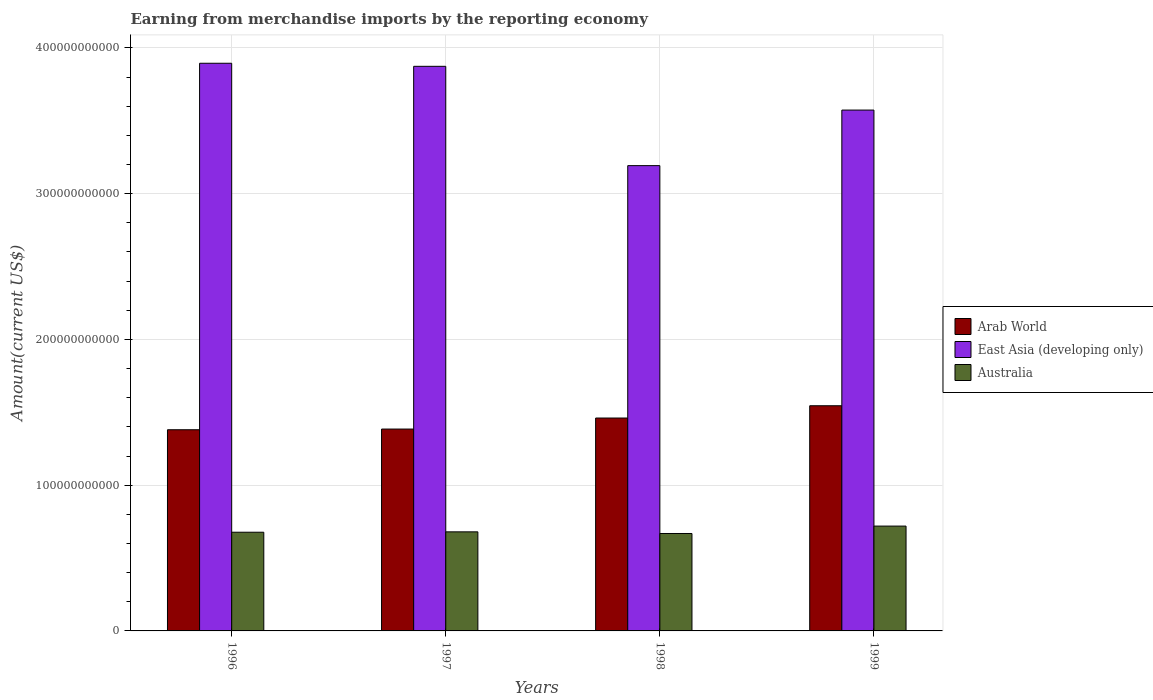How many groups of bars are there?
Offer a very short reply. 4. Are the number of bars per tick equal to the number of legend labels?
Offer a very short reply. Yes. Are the number of bars on each tick of the X-axis equal?
Your answer should be compact. Yes. How many bars are there on the 2nd tick from the left?
Offer a terse response. 3. How many bars are there on the 4th tick from the right?
Your answer should be very brief. 3. In how many cases, is the number of bars for a given year not equal to the number of legend labels?
Your answer should be compact. 0. What is the amount earned from merchandise imports in Australia in 1996?
Your answer should be compact. 6.77e+1. Across all years, what is the maximum amount earned from merchandise imports in Arab World?
Make the answer very short. 1.54e+11. Across all years, what is the minimum amount earned from merchandise imports in East Asia (developing only)?
Keep it short and to the point. 3.19e+11. What is the total amount earned from merchandise imports in Australia in the graph?
Give a very brief answer. 2.74e+11. What is the difference between the amount earned from merchandise imports in East Asia (developing only) in 1998 and that in 1999?
Keep it short and to the point. -3.81e+1. What is the difference between the amount earned from merchandise imports in Arab World in 1998 and the amount earned from merchandise imports in Australia in 1999?
Your answer should be compact. 7.41e+1. What is the average amount earned from merchandise imports in Australia per year?
Offer a terse response. 6.86e+1. In the year 1999, what is the difference between the amount earned from merchandise imports in Arab World and amount earned from merchandise imports in East Asia (developing only)?
Offer a very short reply. -2.03e+11. In how many years, is the amount earned from merchandise imports in Australia greater than 240000000000 US$?
Keep it short and to the point. 0. What is the ratio of the amount earned from merchandise imports in Australia in 1997 to that in 1998?
Your answer should be compact. 1.02. What is the difference between the highest and the second highest amount earned from merchandise imports in Arab World?
Give a very brief answer. 8.42e+09. What is the difference between the highest and the lowest amount earned from merchandise imports in Arab World?
Your answer should be compact. 1.65e+1. What does the 2nd bar from the left in 1996 represents?
Give a very brief answer. East Asia (developing only). What does the 3rd bar from the right in 1998 represents?
Your answer should be very brief. Arab World. Are all the bars in the graph horizontal?
Give a very brief answer. No. What is the difference between two consecutive major ticks on the Y-axis?
Your answer should be compact. 1.00e+11. Does the graph contain grids?
Ensure brevity in your answer.  Yes. How are the legend labels stacked?
Keep it short and to the point. Vertical. What is the title of the graph?
Give a very brief answer. Earning from merchandise imports by the reporting economy. What is the label or title of the X-axis?
Ensure brevity in your answer.  Years. What is the label or title of the Y-axis?
Give a very brief answer. Amount(current US$). What is the Amount(current US$) in Arab World in 1996?
Offer a very short reply. 1.38e+11. What is the Amount(current US$) in East Asia (developing only) in 1996?
Provide a succinct answer. 3.89e+11. What is the Amount(current US$) of Australia in 1996?
Your response must be concise. 6.77e+1. What is the Amount(current US$) in Arab World in 1997?
Provide a short and direct response. 1.38e+11. What is the Amount(current US$) of East Asia (developing only) in 1997?
Your answer should be compact. 3.87e+11. What is the Amount(current US$) of Australia in 1997?
Give a very brief answer. 6.80e+1. What is the Amount(current US$) of Arab World in 1998?
Give a very brief answer. 1.46e+11. What is the Amount(current US$) in East Asia (developing only) in 1998?
Provide a short and direct response. 3.19e+11. What is the Amount(current US$) of Australia in 1998?
Your answer should be compact. 6.69e+1. What is the Amount(current US$) of Arab World in 1999?
Offer a terse response. 1.54e+11. What is the Amount(current US$) in East Asia (developing only) in 1999?
Your answer should be very brief. 3.57e+11. What is the Amount(current US$) of Australia in 1999?
Keep it short and to the point. 7.19e+1. Across all years, what is the maximum Amount(current US$) in Arab World?
Give a very brief answer. 1.54e+11. Across all years, what is the maximum Amount(current US$) of East Asia (developing only)?
Ensure brevity in your answer.  3.89e+11. Across all years, what is the maximum Amount(current US$) of Australia?
Keep it short and to the point. 7.19e+1. Across all years, what is the minimum Amount(current US$) of Arab World?
Your response must be concise. 1.38e+11. Across all years, what is the minimum Amount(current US$) in East Asia (developing only)?
Provide a short and direct response. 3.19e+11. Across all years, what is the minimum Amount(current US$) in Australia?
Ensure brevity in your answer.  6.69e+1. What is the total Amount(current US$) in Arab World in the graph?
Ensure brevity in your answer.  5.77e+11. What is the total Amount(current US$) in East Asia (developing only) in the graph?
Keep it short and to the point. 1.45e+12. What is the total Amount(current US$) of Australia in the graph?
Provide a short and direct response. 2.74e+11. What is the difference between the Amount(current US$) of Arab World in 1996 and that in 1997?
Your response must be concise. -4.70e+08. What is the difference between the Amount(current US$) in East Asia (developing only) in 1996 and that in 1997?
Keep it short and to the point. 2.10e+09. What is the difference between the Amount(current US$) in Australia in 1996 and that in 1997?
Keep it short and to the point. -2.58e+08. What is the difference between the Amount(current US$) of Arab World in 1996 and that in 1998?
Provide a short and direct response. -8.04e+09. What is the difference between the Amount(current US$) of East Asia (developing only) in 1996 and that in 1998?
Your answer should be very brief. 7.02e+1. What is the difference between the Amount(current US$) of Australia in 1996 and that in 1998?
Ensure brevity in your answer.  8.65e+08. What is the difference between the Amount(current US$) of Arab World in 1996 and that in 1999?
Your answer should be very brief. -1.65e+1. What is the difference between the Amount(current US$) in East Asia (developing only) in 1996 and that in 1999?
Keep it short and to the point. 3.21e+1. What is the difference between the Amount(current US$) of Australia in 1996 and that in 1999?
Give a very brief answer. -4.22e+09. What is the difference between the Amount(current US$) of Arab World in 1997 and that in 1998?
Provide a short and direct response. -7.58e+09. What is the difference between the Amount(current US$) in East Asia (developing only) in 1997 and that in 1998?
Make the answer very short. 6.81e+1. What is the difference between the Amount(current US$) of Australia in 1997 and that in 1998?
Give a very brief answer. 1.12e+09. What is the difference between the Amount(current US$) of Arab World in 1997 and that in 1999?
Offer a terse response. -1.60e+1. What is the difference between the Amount(current US$) of East Asia (developing only) in 1997 and that in 1999?
Provide a short and direct response. 3.00e+1. What is the difference between the Amount(current US$) of Australia in 1997 and that in 1999?
Make the answer very short. -3.96e+09. What is the difference between the Amount(current US$) in Arab World in 1998 and that in 1999?
Provide a succinct answer. -8.42e+09. What is the difference between the Amount(current US$) of East Asia (developing only) in 1998 and that in 1999?
Offer a terse response. -3.81e+1. What is the difference between the Amount(current US$) of Australia in 1998 and that in 1999?
Provide a short and direct response. -5.08e+09. What is the difference between the Amount(current US$) of Arab World in 1996 and the Amount(current US$) of East Asia (developing only) in 1997?
Provide a succinct answer. -2.49e+11. What is the difference between the Amount(current US$) in Arab World in 1996 and the Amount(current US$) in Australia in 1997?
Provide a succinct answer. 7.01e+1. What is the difference between the Amount(current US$) in East Asia (developing only) in 1996 and the Amount(current US$) in Australia in 1997?
Your answer should be compact. 3.22e+11. What is the difference between the Amount(current US$) in Arab World in 1996 and the Amount(current US$) in East Asia (developing only) in 1998?
Make the answer very short. -1.81e+11. What is the difference between the Amount(current US$) of Arab World in 1996 and the Amount(current US$) of Australia in 1998?
Your answer should be compact. 7.12e+1. What is the difference between the Amount(current US$) of East Asia (developing only) in 1996 and the Amount(current US$) of Australia in 1998?
Provide a succinct answer. 3.23e+11. What is the difference between the Amount(current US$) in Arab World in 1996 and the Amount(current US$) in East Asia (developing only) in 1999?
Your answer should be very brief. -2.19e+11. What is the difference between the Amount(current US$) in Arab World in 1996 and the Amount(current US$) in Australia in 1999?
Ensure brevity in your answer.  6.61e+1. What is the difference between the Amount(current US$) in East Asia (developing only) in 1996 and the Amount(current US$) in Australia in 1999?
Ensure brevity in your answer.  3.18e+11. What is the difference between the Amount(current US$) in Arab World in 1997 and the Amount(current US$) in East Asia (developing only) in 1998?
Your answer should be very brief. -1.81e+11. What is the difference between the Amount(current US$) in Arab World in 1997 and the Amount(current US$) in Australia in 1998?
Keep it short and to the point. 7.16e+1. What is the difference between the Amount(current US$) of East Asia (developing only) in 1997 and the Amount(current US$) of Australia in 1998?
Make the answer very short. 3.21e+11. What is the difference between the Amount(current US$) in Arab World in 1997 and the Amount(current US$) in East Asia (developing only) in 1999?
Ensure brevity in your answer.  -2.19e+11. What is the difference between the Amount(current US$) of Arab World in 1997 and the Amount(current US$) of Australia in 1999?
Offer a terse response. 6.66e+1. What is the difference between the Amount(current US$) of East Asia (developing only) in 1997 and the Amount(current US$) of Australia in 1999?
Give a very brief answer. 3.15e+11. What is the difference between the Amount(current US$) in Arab World in 1998 and the Amount(current US$) in East Asia (developing only) in 1999?
Your answer should be compact. -2.11e+11. What is the difference between the Amount(current US$) of Arab World in 1998 and the Amount(current US$) of Australia in 1999?
Keep it short and to the point. 7.41e+1. What is the difference between the Amount(current US$) in East Asia (developing only) in 1998 and the Amount(current US$) in Australia in 1999?
Your response must be concise. 2.47e+11. What is the average Amount(current US$) in Arab World per year?
Offer a very short reply. 1.44e+11. What is the average Amount(current US$) in East Asia (developing only) per year?
Provide a short and direct response. 3.63e+11. What is the average Amount(current US$) in Australia per year?
Keep it short and to the point. 6.86e+1. In the year 1996, what is the difference between the Amount(current US$) of Arab World and Amount(current US$) of East Asia (developing only)?
Keep it short and to the point. -2.51e+11. In the year 1996, what is the difference between the Amount(current US$) in Arab World and Amount(current US$) in Australia?
Your response must be concise. 7.03e+1. In the year 1996, what is the difference between the Amount(current US$) in East Asia (developing only) and Amount(current US$) in Australia?
Your answer should be very brief. 3.22e+11. In the year 1997, what is the difference between the Amount(current US$) of Arab World and Amount(current US$) of East Asia (developing only)?
Offer a very short reply. -2.49e+11. In the year 1997, what is the difference between the Amount(current US$) in Arab World and Amount(current US$) in Australia?
Provide a short and direct response. 7.05e+1. In the year 1997, what is the difference between the Amount(current US$) of East Asia (developing only) and Amount(current US$) of Australia?
Provide a short and direct response. 3.19e+11. In the year 1998, what is the difference between the Amount(current US$) in Arab World and Amount(current US$) in East Asia (developing only)?
Your response must be concise. -1.73e+11. In the year 1998, what is the difference between the Amount(current US$) of Arab World and Amount(current US$) of Australia?
Provide a short and direct response. 7.92e+1. In the year 1998, what is the difference between the Amount(current US$) in East Asia (developing only) and Amount(current US$) in Australia?
Give a very brief answer. 2.52e+11. In the year 1999, what is the difference between the Amount(current US$) of Arab World and Amount(current US$) of East Asia (developing only)?
Your response must be concise. -2.03e+11. In the year 1999, what is the difference between the Amount(current US$) of Arab World and Amount(current US$) of Australia?
Your answer should be compact. 8.26e+1. In the year 1999, what is the difference between the Amount(current US$) of East Asia (developing only) and Amount(current US$) of Australia?
Your answer should be very brief. 2.85e+11. What is the ratio of the Amount(current US$) in Arab World in 1996 to that in 1997?
Your answer should be very brief. 1. What is the ratio of the Amount(current US$) in East Asia (developing only) in 1996 to that in 1997?
Keep it short and to the point. 1.01. What is the ratio of the Amount(current US$) of Australia in 1996 to that in 1997?
Keep it short and to the point. 1. What is the ratio of the Amount(current US$) in Arab World in 1996 to that in 1998?
Provide a succinct answer. 0.94. What is the ratio of the Amount(current US$) of East Asia (developing only) in 1996 to that in 1998?
Make the answer very short. 1.22. What is the ratio of the Amount(current US$) in Australia in 1996 to that in 1998?
Give a very brief answer. 1.01. What is the ratio of the Amount(current US$) of Arab World in 1996 to that in 1999?
Keep it short and to the point. 0.89. What is the ratio of the Amount(current US$) of East Asia (developing only) in 1996 to that in 1999?
Keep it short and to the point. 1.09. What is the ratio of the Amount(current US$) in Australia in 1996 to that in 1999?
Offer a terse response. 0.94. What is the ratio of the Amount(current US$) of Arab World in 1997 to that in 1998?
Provide a succinct answer. 0.95. What is the ratio of the Amount(current US$) of East Asia (developing only) in 1997 to that in 1998?
Your response must be concise. 1.21. What is the ratio of the Amount(current US$) of Australia in 1997 to that in 1998?
Provide a succinct answer. 1.02. What is the ratio of the Amount(current US$) in Arab World in 1997 to that in 1999?
Your answer should be very brief. 0.9. What is the ratio of the Amount(current US$) in East Asia (developing only) in 1997 to that in 1999?
Provide a succinct answer. 1.08. What is the ratio of the Amount(current US$) of Australia in 1997 to that in 1999?
Offer a terse response. 0.94. What is the ratio of the Amount(current US$) in Arab World in 1998 to that in 1999?
Offer a terse response. 0.95. What is the ratio of the Amount(current US$) in East Asia (developing only) in 1998 to that in 1999?
Your response must be concise. 0.89. What is the ratio of the Amount(current US$) in Australia in 1998 to that in 1999?
Keep it short and to the point. 0.93. What is the difference between the highest and the second highest Amount(current US$) in Arab World?
Ensure brevity in your answer.  8.42e+09. What is the difference between the highest and the second highest Amount(current US$) of East Asia (developing only)?
Ensure brevity in your answer.  2.10e+09. What is the difference between the highest and the second highest Amount(current US$) of Australia?
Your response must be concise. 3.96e+09. What is the difference between the highest and the lowest Amount(current US$) of Arab World?
Make the answer very short. 1.65e+1. What is the difference between the highest and the lowest Amount(current US$) in East Asia (developing only)?
Provide a succinct answer. 7.02e+1. What is the difference between the highest and the lowest Amount(current US$) of Australia?
Make the answer very short. 5.08e+09. 